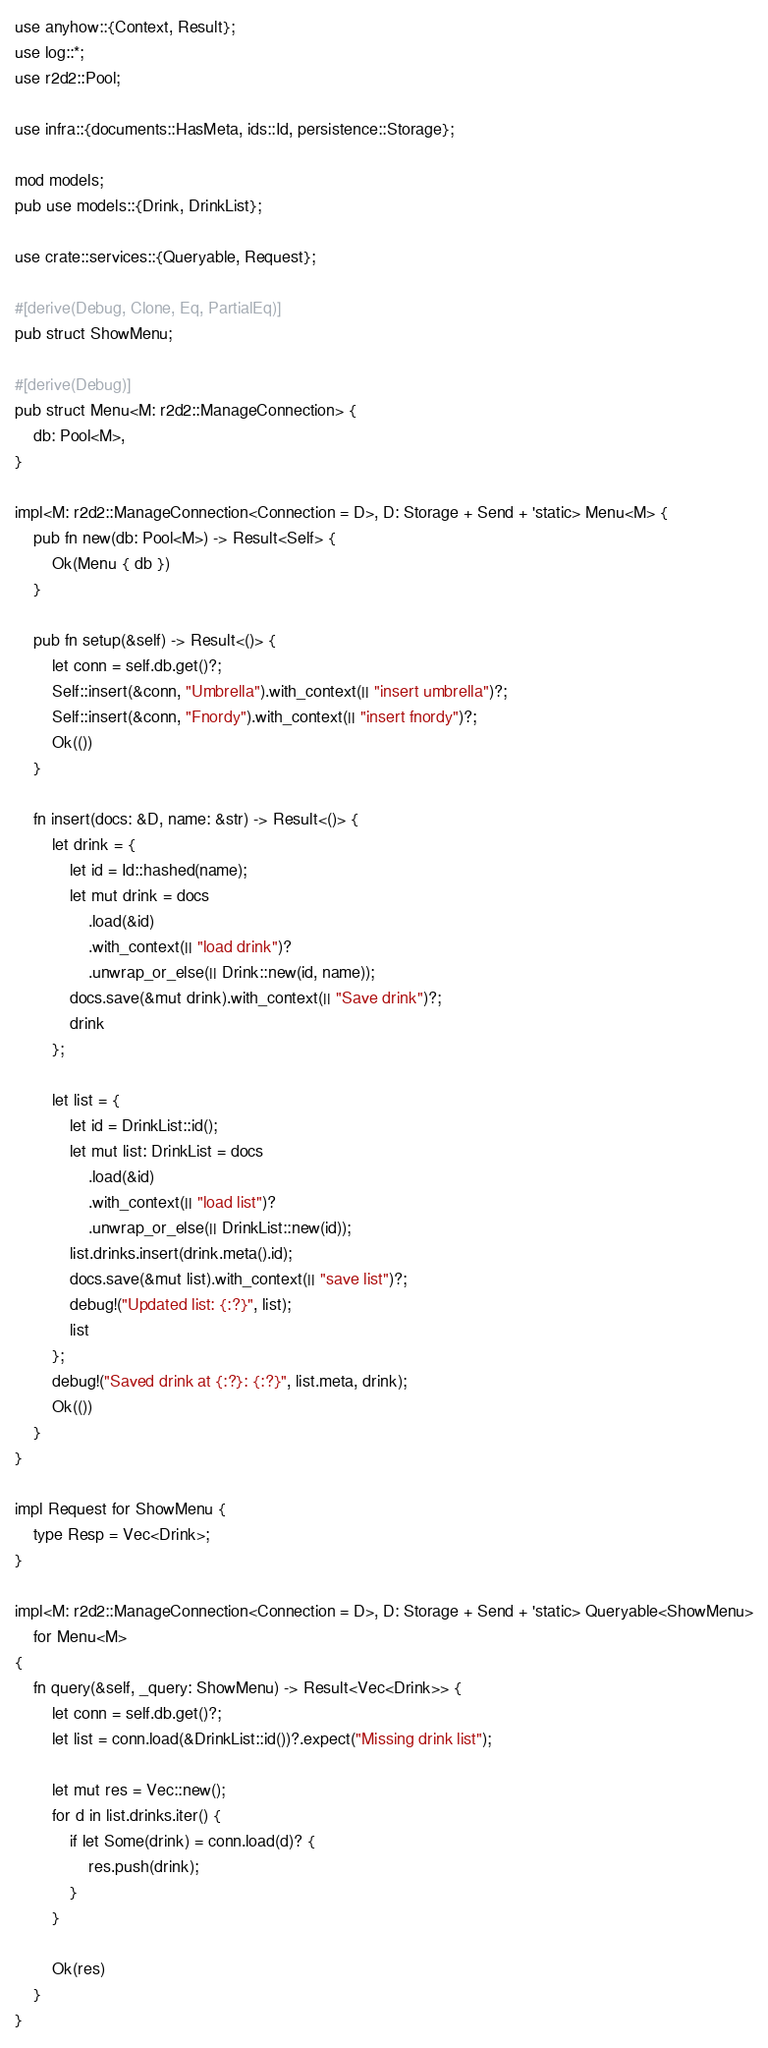<code> <loc_0><loc_0><loc_500><loc_500><_Rust_>use anyhow::{Context, Result};
use log::*;
use r2d2::Pool;

use infra::{documents::HasMeta, ids::Id, persistence::Storage};

mod models;
pub use models::{Drink, DrinkList};

use crate::services::{Queryable, Request};

#[derive(Debug, Clone, Eq, PartialEq)]
pub struct ShowMenu;

#[derive(Debug)]
pub struct Menu<M: r2d2::ManageConnection> {
    db: Pool<M>,
}

impl<M: r2d2::ManageConnection<Connection = D>, D: Storage + Send + 'static> Menu<M> {
    pub fn new(db: Pool<M>) -> Result<Self> {
        Ok(Menu { db })
    }

    pub fn setup(&self) -> Result<()> {
        let conn = self.db.get()?;
        Self::insert(&conn, "Umbrella").with_context(|| "insert umbrella")?;
        Self::insert(&conn, "Fnordy").with_context(|| "insert fnordy")?;
        Ok(())
    }

    fn insert(docs: &D, name: &str) -> Result<()> {
        let drink = {
            let id = Id::hashed(name);
            let mut drink = docs
                .load(&id)
                .with_context(|| "load drink")?
                .unwrap_or_else(|| Drink::new(id, name));
            docs.save(&mut drink).with_context(|| "Save drink")?;
            drink
        };

        let list = {
            let id = DrinkList::id();
            let mut list: DrinkList = docs
                .load(&id)
                .with_context(|| "load list")?
                .unwrap_or_else(|| DrinkList::new(id));
            list.drinks.insert(drink.meta().id);
            docs.save(&mut list).with_context(|| "save list")?;
            debug!("Updated list: {:?}", list);
            list
        };
        debug!("Saved drink at {:?}: {:?}", list.meta, drink);
        Ok(())
    }
}

impl Request for ShowMenu {
    type Resp = Vec<Drink>;
}

impl<M: r2d2::ManageConnection<Connection = D>, D: Storage + Send + 'static> Queryable<ShowMenu>
    for Menu<M>
{
    fn query(&self, _query: ShowMenu) -> Result<Vec<Drink>> {
        let conn = self.db.get()?;
        let list = conn.load(&DrinkList::id())?.expect("Missing drink list");

        let mut res = Vec::new();
        for d in list.drinks.iter() {
            if let Some(drink) = conn.load(d)? {
                res.push(drink);
            }
        }

        Ok(res)
    }
}
</code> 